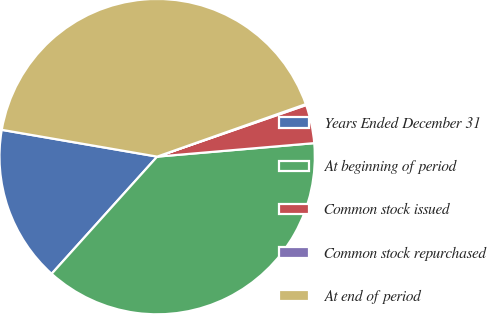Convert chart to OTSL. <chart><loc_0><loc_0><loc_500><loc_500><pie_chart><fcel>Years Ended December 31<fcel>At beginning of period<fcel>Common stock issued<fcel>Common stock repurchased<fcel>At end of period<nl><fcel>16.05%<fcel>38.03%<fcel>3.94%<fcel>0.1%<fcel>41.88%<nl></chart> 